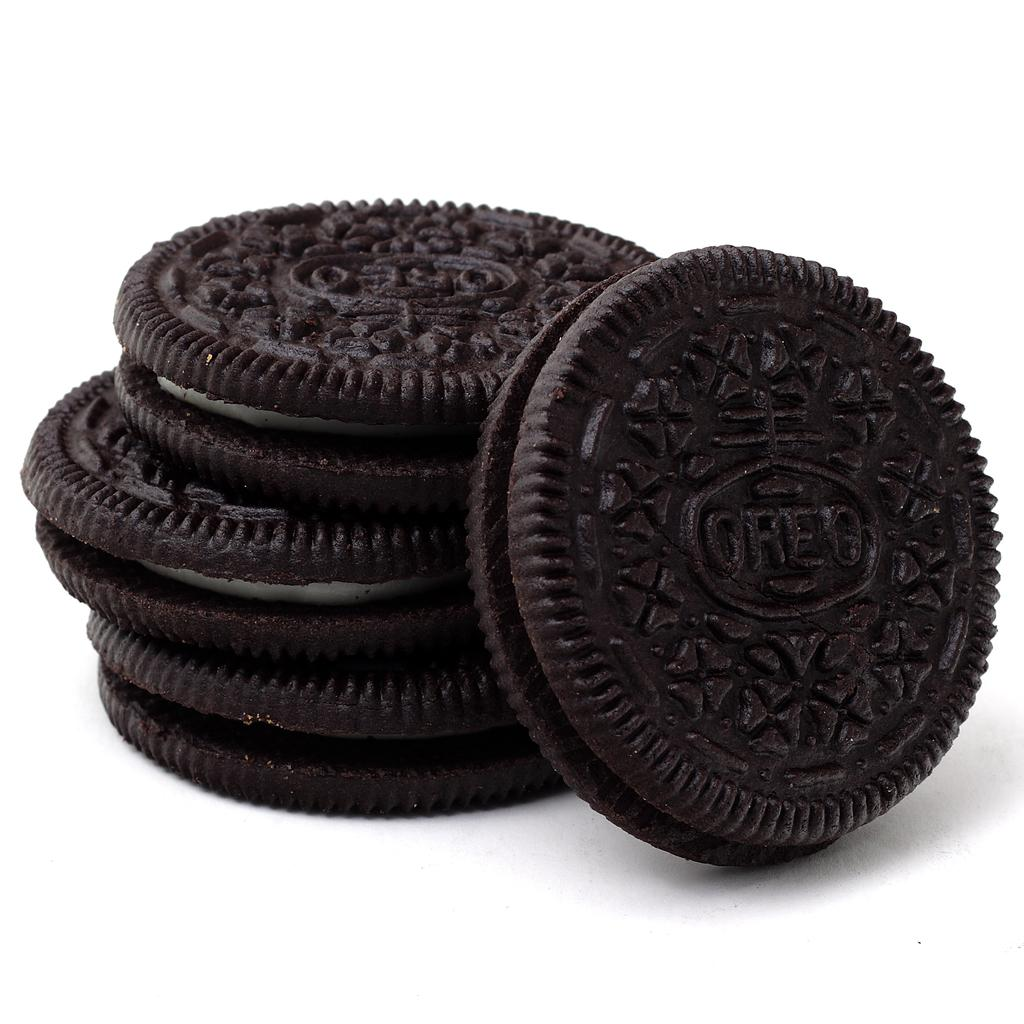How many Oreo cookies are visible in the image? There are four Oreo cookies in the image. What is the color of the Oreo cookies? The Oreo cookies are black in color. What is the filling between the Oreo cookies? There is cream between the cookies. What color is the background of the image? The background of the image appears to be white. Can you see any basketball players in the image? There are no basketball players present in the image. Is there any blood visible on the Oreo cookies? There is no blood visible on the Oreo cookies; they are simply black cookies with cream filling. 